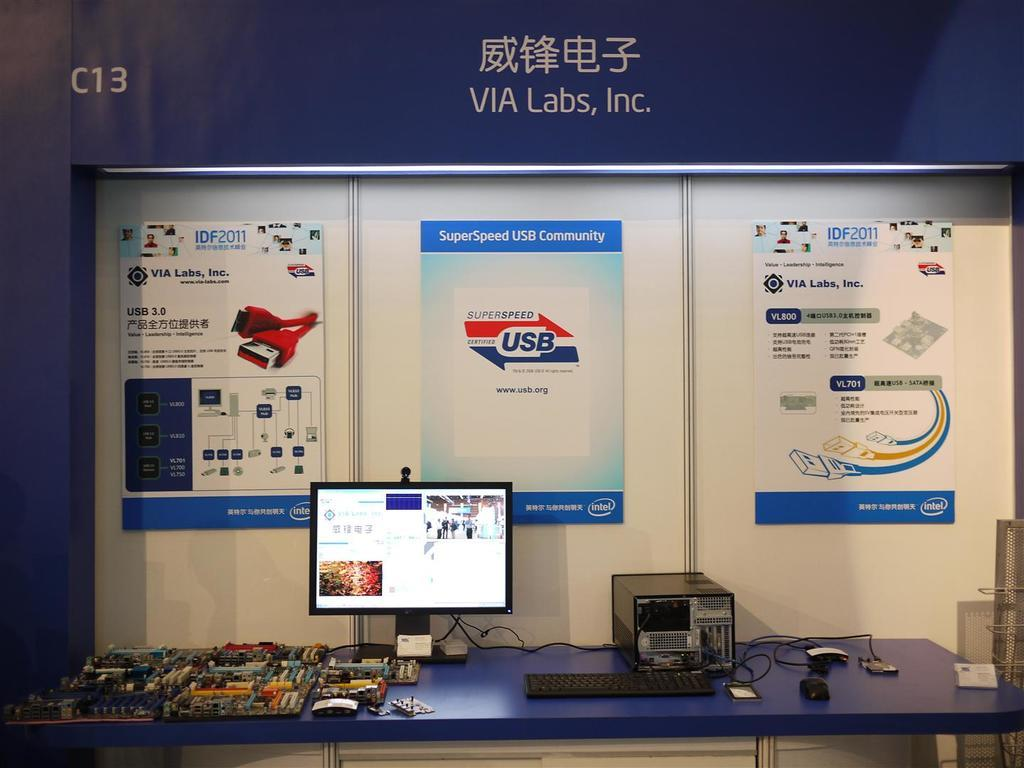Provide a one-sentence caption for the provided image. a circuit board with C13 and Via labs inc written on it. 